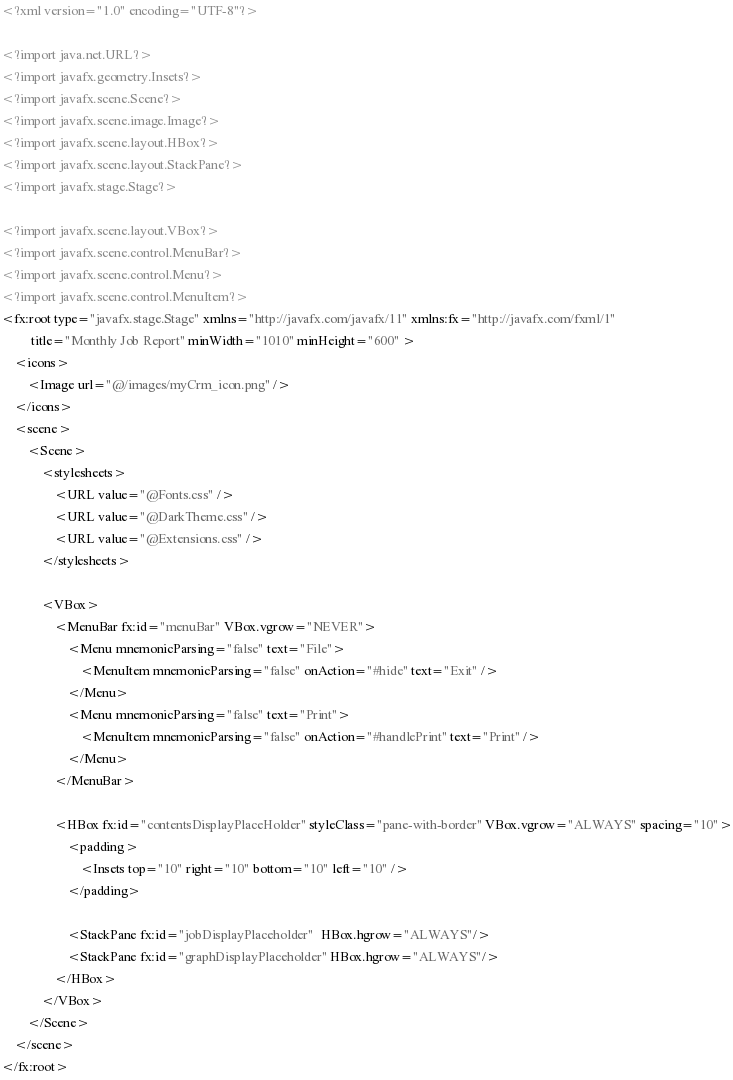<code> <loc_0><loc_0><loc_500><loc_500><_XML_><?xml version="1.0" encoding="UTF-8"?>

<?import java.net.URL?>
<?import javafx.geometry.Insets?>
<?import javafx.scene.Scene?>
<?import javafx.scene.image.Image?>
<?import javafx.scene.layout.HBox?>
<?import javafx.scene.layout.StackPane?>
<?import javafx.stage.Stage?>

<?import javafx.scene.layout.VBox?>
<?import javafx.scene.control.MenuBar?>
<?import javafx.scene.control.Menu?>
<?import javafx.scene.control.MenuItem?>
<fx:root type="javafx.stage.Stage" xmlns="http://javafx.com/javafx/11" xmlns:fx="http://javafx.com/fxml/1"
         title="Monthly Job Report" minWidth="1010" minHeight="600" >
    <icons>
        <Image url="@/images/myCrm_icon.png" />
    </icons>
    <scene>
        <Scene>
            <stylesheets>
                <URL value="@Fonts.css" />
                <URL value="@DarkTheme.css" />
                <URL value="@Extensions.css" />
            </stylesheets>

            <VBox>
                <MenuBar fx:id="menuBar" VBox.vgrow="NEVER">
                    <Menu mnemonicParsing="false" text="File">
                        <MenuItem mnemonicParsing="false" onAction="#hide" text="Exit" />
                    </Menu>
                    <Menu mnemonicParsing="false" text="Print">
                        <MenuItem mnemonicParsing="false" onAction="#handlePrint" text="Print" />
                    </Menu>
                </MenuBar>

                <HBox fx:id="contentsDisplayPlaceHolder" styleClass="pane-with-border" VBox.vgrow="ALWAYS" spacing="10">
                    <padding>
                        <Insets top="10" right="10" bottom="10" left="10" />
                    </padding>

                    <StackPane fx:id="jobDisplayPlaceholder"  HBox.hgrow="ALWAYS"/>
                    <StackPane fx:id="graphDisplayPlaceholder" HBox.hgrow="ALWAYS"/>
                </HBox>
            </VBox>
        </Scene>
    </scene>
</fx:root>
</code> 